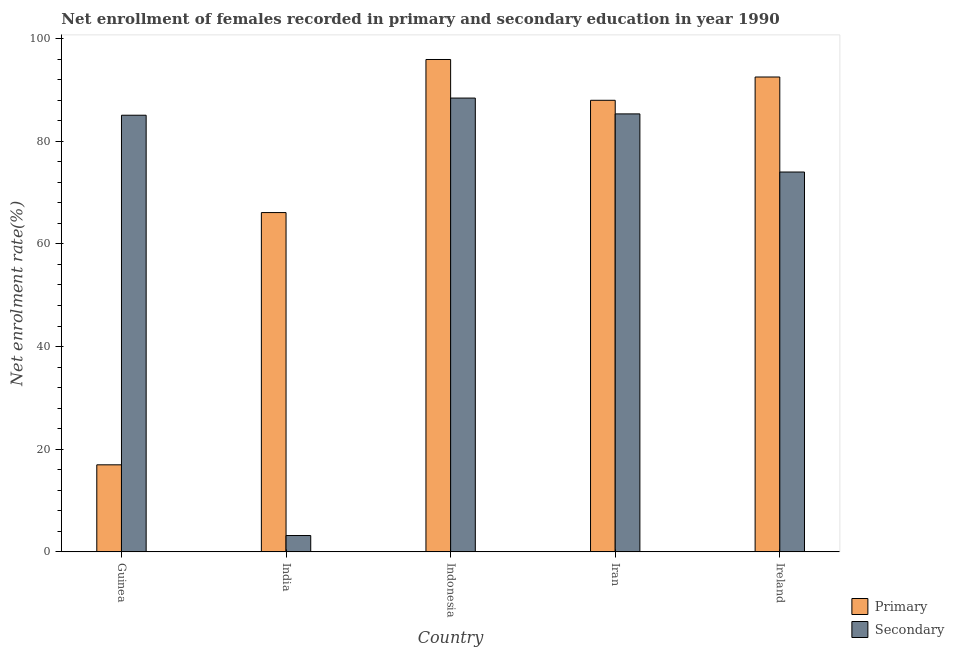Are the number of bars per tick equal to the number of legend labels?
Keep it short and to the point. Yes. What is the label of the 1st group of bars from the left?
Ensure brevity in your answer.  Guinea. In how many cases, is the number of bars for a given country not equal to the number of legend labels?
Give a very brief answer. 0. What is the enrollment rate in primary education in Iran?
Provide a succinct answer. 87.99. Across all countries, what is the maximum enrollment rate in primary education?
Keep it short and to the point. 95.94. Across all countries, what is the minimum enrollment rate in secondary education?
Ensure brevity in your answer.  3.19. In which country was the enrollment rate in secondary education maximum?
Offer a terse response. Indonesia. In which country was the enrollment rate in secondary education minimum?
Provide a succinct answer. India. What is the total enrollment rate in primary education in the graph?
Offer a very short reply. 359.53. What is the difference between the enrollment rate in secondary education in Guinea and that in India?
Provide a succinct answer. 81.89. What is the difference between the enrollment rate in primary education in Iran and the enrollment rate in secondary education in Ireland?
Make the answer very short. 13.98. What is the average enrollment rate in primary education per country?
Offer a terse response. 71.91. What is the difference between the enrollment rate in primary education and enrollment rate in secondary education in Ireland?
Keep it short and to the point. 18.51. What is the ratio of the enrollment rate in secondary education in Iran to that in Ireland?
Keep it short and to the point. 1.15. Is the difference between the enrollment rate in secondary education in India and Iran greater than the difference between the enrollment rate in primary education in India and Iran?
Provide a short and direct response. No. What is the difference between the highest and the second highest enrollment rate in primary education?
Provide a short and direct response. 3.41. What is the difference between the highest and the lowest enrollment rate in secondary education?
Keep it short and to the point. 85.24. In how many countries, is the enrollment rate in primary education greater than the average enrollment rate in primary education taken over all countries?
Give a very brief answer. 3. What does the 2nd bar from the left in India represents?
Make the answer very short. Secondary. What does the 2nd bar from the right in Iran represents?
Your answer should be compact. Primary. Are all the bars in the graph horizontal?
Give a very brief answer. No. How many countries are there in the graph?
Your response must be concise. 5. Are the values on the major ticks of Y-axis written in scientific E-notation?
Ensure brevity in your answer.  No. Where does the legend appear in the graph?
Ensure brevity in your answer.  Bottom right. How many legend labels are there?
Make the answer very short. 2. What is the title of the graph?
Ensure brevity in your answer.  Net enrollment of females recorded in primary and secondary education in year 1990. Does "Investment in Telecom" appear as one of the legend labels in the graph?
Offer a very short reply. No. What is the label or title of the Y-axis?
Ensure brevity in your answer.  Net enrolment rate(%). What is the Net enrolment rate(%) in Primary in Guinea?
Make the answer very short. 16.96. What is the Net enrolment rate(%) of Secondary in Guinea?
Make the answer very short. 85.08. What is the Net enrolment rate(%) of Primary in India?
Provide a succinct answer. 66.11. What is the Net enrolment rate(%) in Secondary in India?
Your answer should be compact. 3.19. What is the Net enrolment rate(%) in Primary in Indonesia?
Provide a succinct answer. 95.94. What is the Net enrolment rate(%) in Secondary in Indonesia?
Make the answer very short. 88.42. What is the Net enrolment rate(%) in Primary in Iran?
Provide a short and direct response. 87.99. What is the Net enrolment rate(%) in Secondary in Iran?
Keep it short and to the point. 85.34. What is the Net enrolment rate(%) in Primary in Ireland?
Give a very brief answer. 92.53. What is the Net enrolment rate(%) of Secondary in Ireland?
Keep it short and to the point. 74.01. Across all countries, what is the maximum Net enrolment rate(%) of Primary?
Offer a very short reply. 95.94. Across all countries, what is the maximum Net enrolment rate(%) in Secondary?
Provide a succinct answer. 88.42. Across all countries, what is the minimum Net enrolment rate(%) of Primary?
Offer a terse response. 16.96. Across all countries, what is the minimum Net enrolment rate(%) of Secondary?
Provide a short and direct response. 3.19. What is the total Net enrolment rate(%) in Primary in the graph?
Your response must be concise. 359.53. What is the total Net enrolment rate(%) of Secondary in the graph?
Give a very brief answer. 336.04. What is the difference between the Net enrolment rate(%) of Primary in Guinea and that in India?
Your response must be concise. -49.15. What is the difference between the Net enrolment rate(%) of Secondary in Guinea and that in India?
Give a very brief answer. 81.89. What is the difference between the Net enrolment rate(%) in Primary in Guinea and that in Indonesia?
Your answer should be very brief. -78.98. What is the difference between the Net enrolment rate(%) of Secondary in Guinea and that in Indonesia?
Give a very brief answer. -3.34. What is the difference between the Net enrolment rate(%) in Primary in Guinea and that in Iran?
Keep it short and to the point. -71.03. What is the difference between the Net enrolment rate(%) of Secondary in Guinea and that in Iran?
Your response must be concise. -0.26. What is the difference between the Net enrolment rate(%) of Primary in Guinea and that in Ireland?
Your answer should be very brief. -75.56. What is the difference between the Net enrolment rate(%) of Secondary in Guinea and that in Ireland?
Offer a terse response. 11.06. What is the difference between the Net enrolment rate(%) in Primary in India and that in Indonesia?
Offer a terse response. -29.83. What is the difference between the Net enrolment rate(%) of Secondary in India and that in Indonesia?
Your answer should be compact. -85.24. What is the difference between the Net enrolment rate(%) of Primary in India and that in Iran?
Ensure brevity in your answer.  -21.88. What is the difference between the Net enrolment rate(%) of Secondary in India and that in Iran?
Make the answer very short. -82.15. What is the difference between the Net enrolment rate(%) of Primary in India and that in Ireland?
Keep it short and to the point. -26.42. What is the difference between the Net enrolment rate(%) of Secondary in India and that in Ireland?
Give a very brief answer. -70.83. What is the difference between the Net enrolment rate(%) in Primary in Indonesia and that in Iran?
Provide a succinct answer. 7.95. What is the difference between the Net enrolment rate(%) of Secondary in Indonesia and that in Iran?
Make the answer very short. 3.08. What is the difference between the Net enrolment rate(%) of Primary in Indonesia and that in Ireland?
Offer a terse response. 3.41. What is the difference between the Net enrolment rate(%) of Secondary in Indonesia and that in Ireland?
Offer a terse response. 14.41. What is the difference between the Net enrolment rate(%) in Primary in Iran and that in Ireland?
Your response must be concise. -4.54. What is the difference between the Net enrolment rate(%) in Secondary in Iran and that in Ireland?
Keep it short and to the point. 11.33. What is the difference between the Net enrolment rate(%) in Primary in Guinea and the Net enrolment rate(%) in Secondary in India?
Your answer should be very brief. 13.78. What is the difference between the Net enrolment rate(%) in Primary in Guinea and the Net enrolment rate(%) in Secondary in Indonesia?
Provide a succinct answer. -71.46. What is the difference between the Net enrolment rate(%) of Primary in Guinea and the Net enrolment rate(%) of Secondary in Iran?
Ensure brevity in your answer.  -68.38. What is the difference between the Net enrolment rate(%) of Primary in Guinea and the Net enrolment rate(%) of Secondary in Ireland?
Offer a very short reply. -57.05. What is the difference between the Net enrolment rate(%) in Primary in India and the Net enrolment rate(%) in Secondary in Indonesia?
Ensure brevity in your answer.  -22.31. What is the difference between the Net enrolment rate(%) in Primary in India and the Net enrolment rate(%) in Secondary in Iran?
Provide a succinct answer. -19.23. What is the difference between the Net enrolment rate(%) in Primary in India and the Net enrolment rate(%) in Secondary in Ireland?
Offer a very short reply. -7.9. What is the difference between the Net enrolment rate(%) of Primary in Indonesia and the Net enrolment rate(%) of Secondary in Iran?
Provide a succinct answer. 10.6. What is the difference between the Net enrolment rate(%) in Primary in Indonesia and the Net enrolment rate(%) in Secondary in Ireland?
Offer a terse response. 21.93. What is the difference between the Net enrolment rate(%) of Primary in Iran and the Net enrolment rate(%) of Secondary in Ireland?
Provide a short and direct response. 13.98. What is the average Net enrolment rate(%) in Primary per country?
Offer a terse response. 71.91. What is the average Net enrolment rate(%) of Secondary per country?
Make the answer very short. 67.21. What is the difference between the Net enrolment rate(%) in Primary and Net enrolment rate(%) in Secondary in Guinea?
Provide a succinct answer. -68.12. What is the difference between the Net enrolment rate(%) of Primary and Net enrolment rate(%) of Secondary in India?
Ensure brevity in your answer.  62.92. What is the difference between the Net enrolment rate(%) of Primary and Net enrolment rate(%) of Secondary in Indonesia?
Offer a very short reply. 7.52. What is the difference between the Net enrolment rate(%) in Primary and Net enrolment rate(%) in Secondary in Iran?
Give a very brief answer. 2.65. What is the difference between the Net enrolment rate(%) in Primary and Net enrolment rate(%) in Secondary in Ireland?
Offer a terse response. 18.51. What is the ratio of the Net enrolment rate(%) of Primary in Guinea to that in India?
Provide a short and direct response. 0.26. What is the ratio of the Net enrolment rate(%) of Secondary in Guinea to that in India?
Offer a terse response. 26.7. What is the ratio of the Net enrolment rate(%) in Primary in Guinea to that in Indonesia?
Give a very brief answer. 0.18. What is the ratio of the Net enrolment rate(%) in Secondary in Guinea to that in Indonesia?
Provide a succinct answer. 0.96. What is the ratio of the Net enrolment rate(%) of Primary in Guinea to that in Iran?
Your answer should be compact. 0.19. What is the ratio of the Net enrolment rate(%) of Primary in Guinea to that in Ireland?
Keep it short and to the point. 0.18. What is the ratio of the Net enrolment rate(%) in Secondary in Guinea to that in Ireland?
Provide a succinct answer. 1.15. What is the ratio of the Net enrolment rate(%) in Primary in India to that in Indonesia?
Make the answer very short. 0.69. What is the ratio of the Net enrolment rate(%) in Secondary in India to that in Indonesia?
Your answer should be compact. 0.04. What is the ratio of the Net enrolment rate(%) in Primary in India to that in Iran?
Your answer should be compact. 0.75. What is the ratio of the Net enrolment rate(%) in Secondary in India to that in Iran?
Ensure brevity in your answer.  0.04. What is the ratio of the Net enrolment rate(%) of Primary in India to that in Ireland?
Offer a very short reply. 0.71. What is the ratio of the Net enrolment rate(%) in Secondary in India to that in Ireland?
Your answer should be compact. 0.04. What is the ratio of the Net enrolment rate(%) of Primary in Indonesia to that in Iran?
Ensure brevity in your answer.  1.09. What is the ratio of the Net enrolment rate(%) in Secondary in Indonesia to that in Iran?
Ensure brevity in your answer.  1.04. What is the ratio of the Net enrolment rate(%) in Primary in Indonesia to that in Ireland?
Make the answer very short. 1.04. What is the ratio of the Net enrolment rate(%) of Secondary in Indonesia to that in Ireland?
Your answer should be very brief. 1.19. What is the ratio of the Net enrolment rate(%) in Primary in Iran to that in Ireland?
Your response must be concise. 0.95. What is the ratio of the Net enrolment rate(%) of Secondary in Iran to that in Ireland?
Offer a very short reply. 1.15. What is the difference between the highest and the second highest Net enrolment rate(%) of Primary?
Ensure brevity in your answer.  3.41. What is the difference between the highest and the second highest Net enrolment rate(%) in Secondary?
Provide a succinct answer. 3.08. What is the difference between the highest and the lowest Net enrolment rate(%) of Primary?
Provide a short and direct response. 78.98. What is the difference between the highest and the lowest Net enrolment rate(%) in Secondary?
Your answer should be very brief. 85.24. 